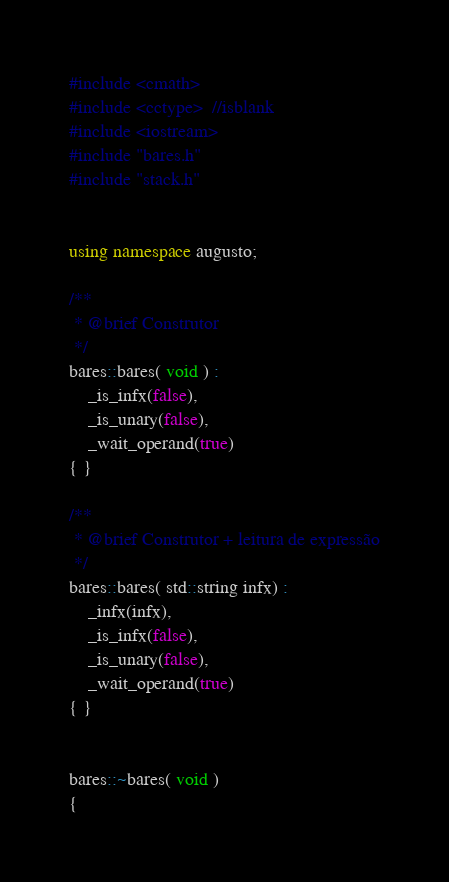<code> <loc_0><loc_0><loc_500><loc_500><_C++_>#include <cmath>
#include <cctype>  //isblank
#include <iostream>
#include "bares.h"
#include "stack.h"


using namespace augusto;

/**
 * @brief Construtor
 */
bares::bares( void ) : 
	_is_infx(false),
	_is_unary(false),
	_wait_operand(true)
{ }

/**
 * @brief Construtor + leitura de expressão
 */
bares::bares( std::string infx) : 
	_infx(infx),
	_is_infx(false),
	_is_unary(false),
	_wait_operand(true)
{ }


bares::~bares( void )
{</code> 